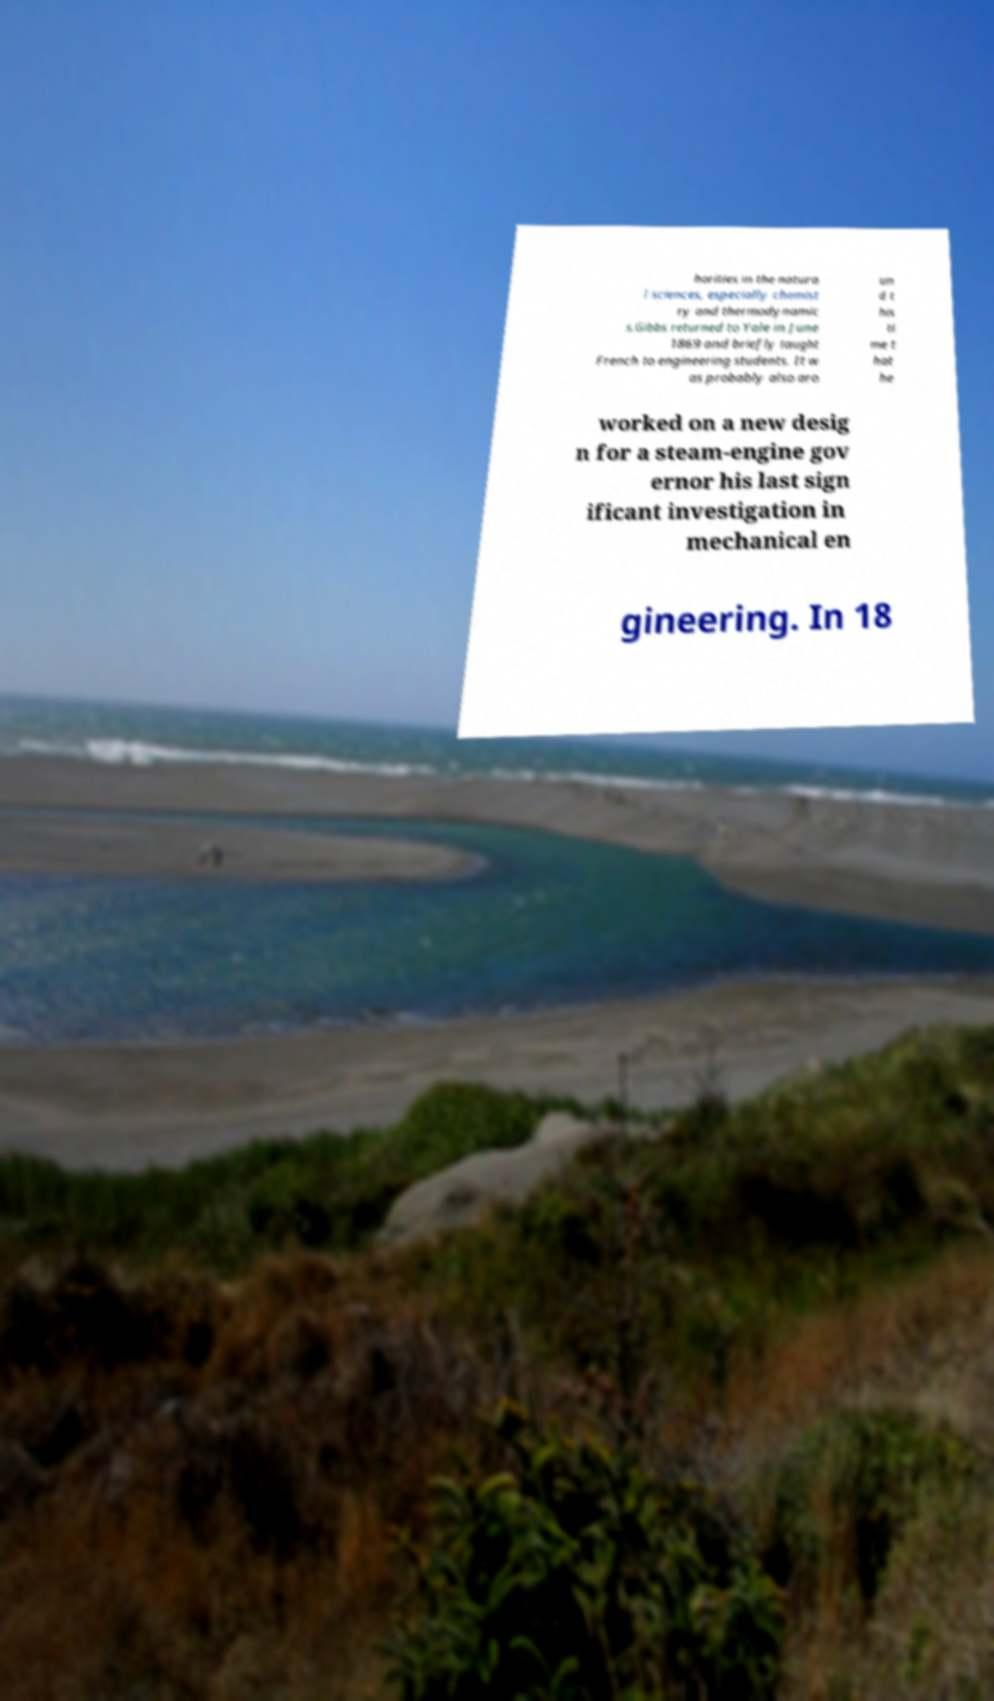Can you accurately transcribe the text from the provided image for me? horities in the natura l sciences, especially chemist ry and thermodynamic s.Gibbs returned to Yale in June 1869 and briefly taught French to engineering students. It w as probably also aro un d t his ti me t hat he worked on a new desig n for a steam-engine gov ernor his last sign ificant investigation in mechanical en gineering. In 18 